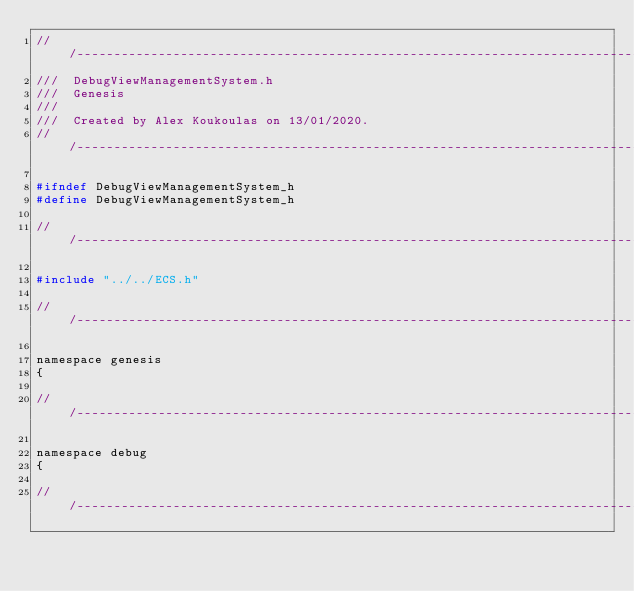Convert code to text. <code><loc_0><loc_0><loc_500><loc_500><_C_>///------------------------------------------------------------------------------------------------
///  DebugViewManagementSystem.h
///  Genesis
///
///  Created by Alex Koukoulas on 13/01/2020.
///-----------------------------------------------------------------------------------------------

#ifndef DebugViewManagementSystem_h
#define DebugViewManagementSystem_h

///-----------------------------------------------------------------------------------------------

#include "../../ECS.h"

///-----------------------------------------------------------------------------------------------

namespace genesis
{

///-----------------------------------------------------------------------------------------------

namespace debug
{

///-----------------------------------------------------------------------------------------------</code> 